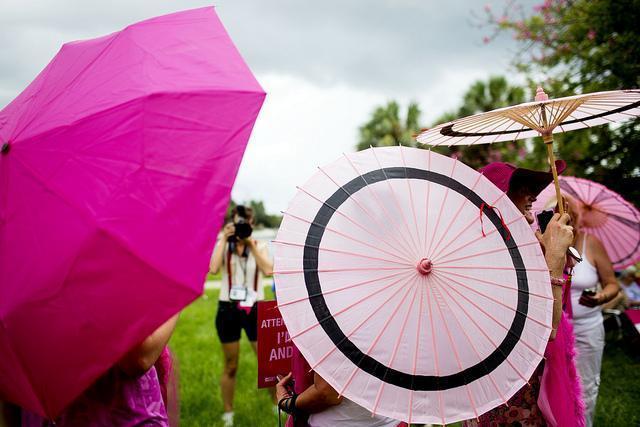How many umbrellas are shown?
Give a very brief answer. 4. How many umbrellas can be seen?
Give a very brief answer. 4. How many people can be seen?
Give a very brief answer. 2. How many umbrellas are in the photo?
Give a very brief answer. 4. 